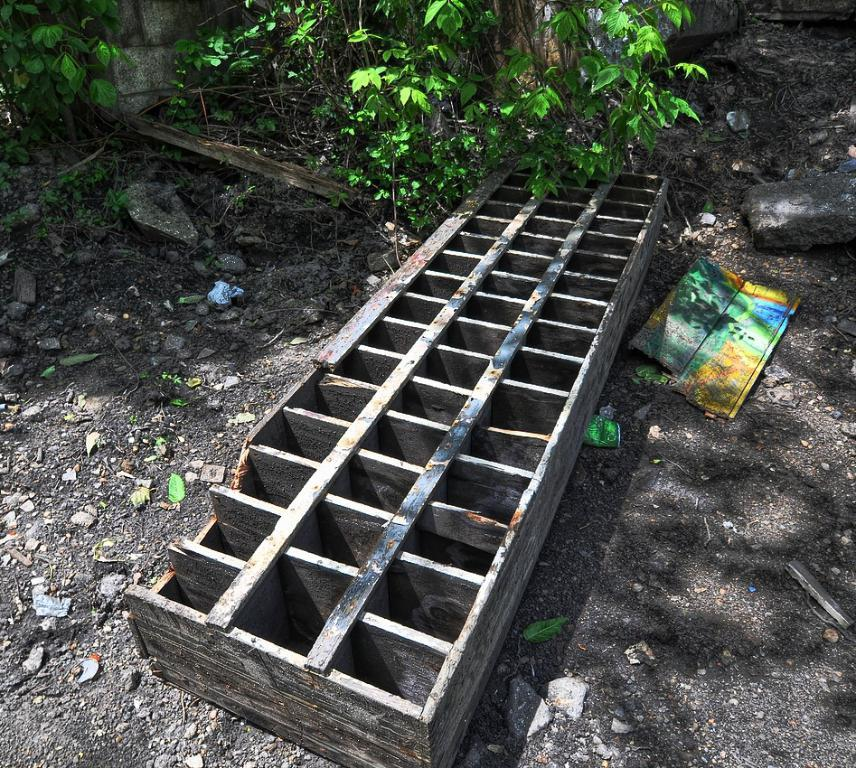What type of material is the wooden object made of in the image? The wooden object in the image is made of wood. What other objects can be seen on the ground in the image? There are rocks and other objects on the ground in the image. What can be seen in the background of the image? There are plants in the background of the image. Is the wooden object being used for reading in the image? There is no indication in the image that the wooden object is being used for reading. 